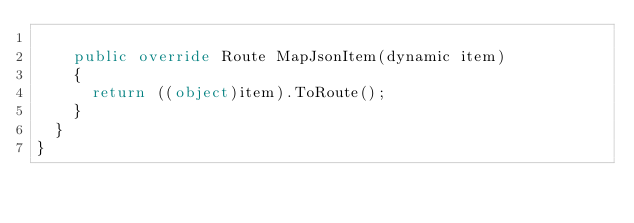Convert code to text. <code><loc_0><loc_0><loc_500><loc_500><_C#_>
		public override Route MapJsonItem(dynamic item)
		{
			return ((object)item).ToRoute();
		}
	}
}</code> 